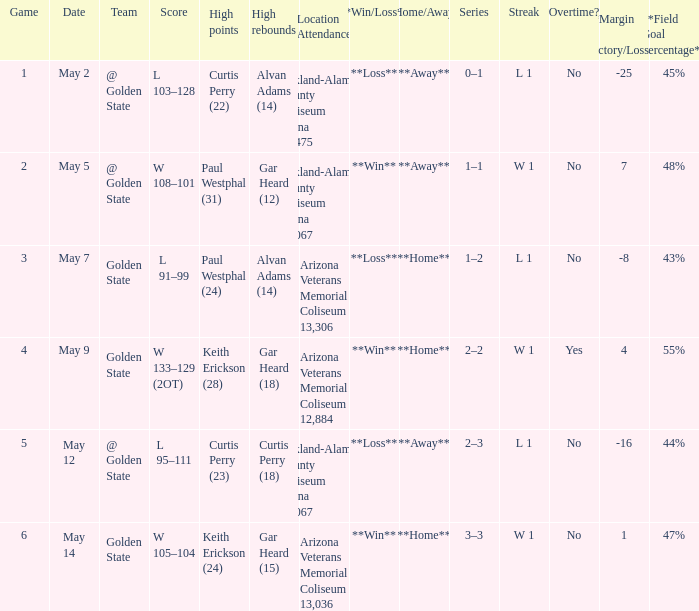How many games had they won or lost in a row on May 9? W 1. 